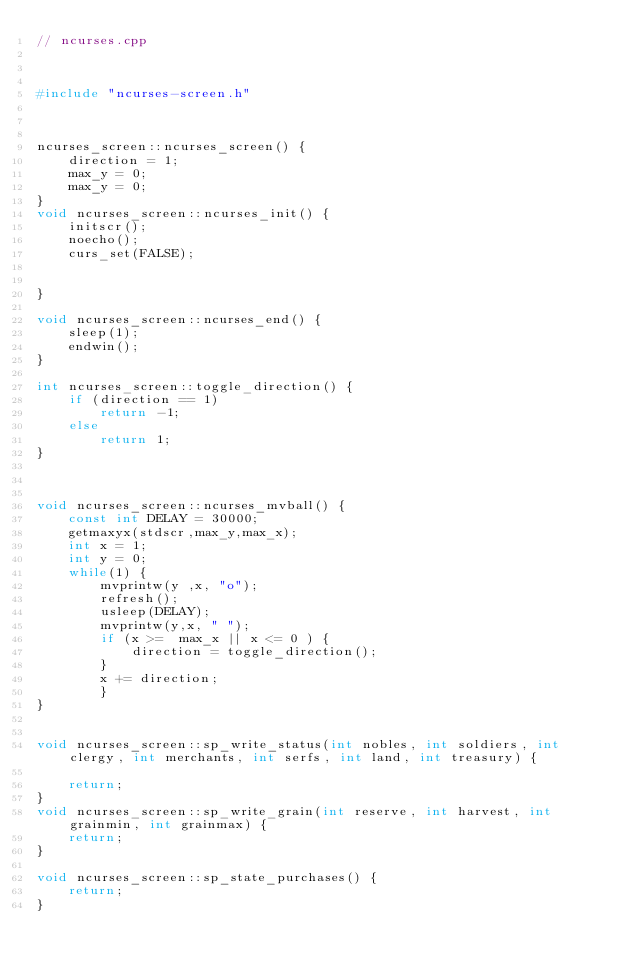<code> <loc_0><loc_0><loc_500><loc_500><_C++_>// ncurses.cpp



#include "ncurses-screen.h"



ncurses_screen::ncurses_screen() {
    direction = 1;
    max_y = 0;
    max_y = 0;
}
void ncurses_screen::ncurses_init() {
    initscr();
    noecho();
    curs_set(FALSE);
    
    
}

void ncurses_screen::ncurses_end() {
    sleep(1);
    endwin();
}

int ncurses_screen::toggle_direction() {
    if (direction == 1)
        return -1;
    else 
        return 1;
}



void ncurses_screen::ncurses_mvball() {
    const int DELAY = 30000;
    getmaxyx(stdscr,max_y,max_x);
    int x = 1;
    int y = 0;
    while(1) {    
        mvprintw(y ,x, "o");
        refresh();
        usleep(DELAY);
        mvprintw(y,x, " ");
        if (x >=  max_x || x <= 0 ) { 
            direction = toggle_direction();
        }
        x += direction;
        }
}


void ncurses_screen::sp_write_status(int nobles, int soldiers, int clergy, int merchants, int serfs, int land, int treasury) {
    
    return;
}
void ncurses_screen::sp_write_grain(int reserve, int harvest, int grainmin, int grainmax) {
    return;
}

void ncurses_screen::sp_state_purchases() {
    return;
}

</code> 